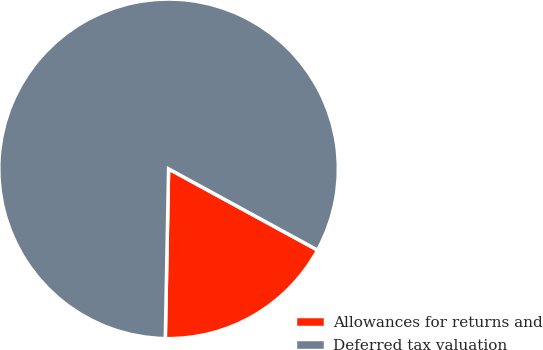Convert chart. <chart><loc_0><loc_0><loc_500><loc_500><pie_chart><fcel>Allowances for returns and<fcel>Deferred tax valuation<nl><fcel>17.36%<fcel>82.64%<nl></chart> 